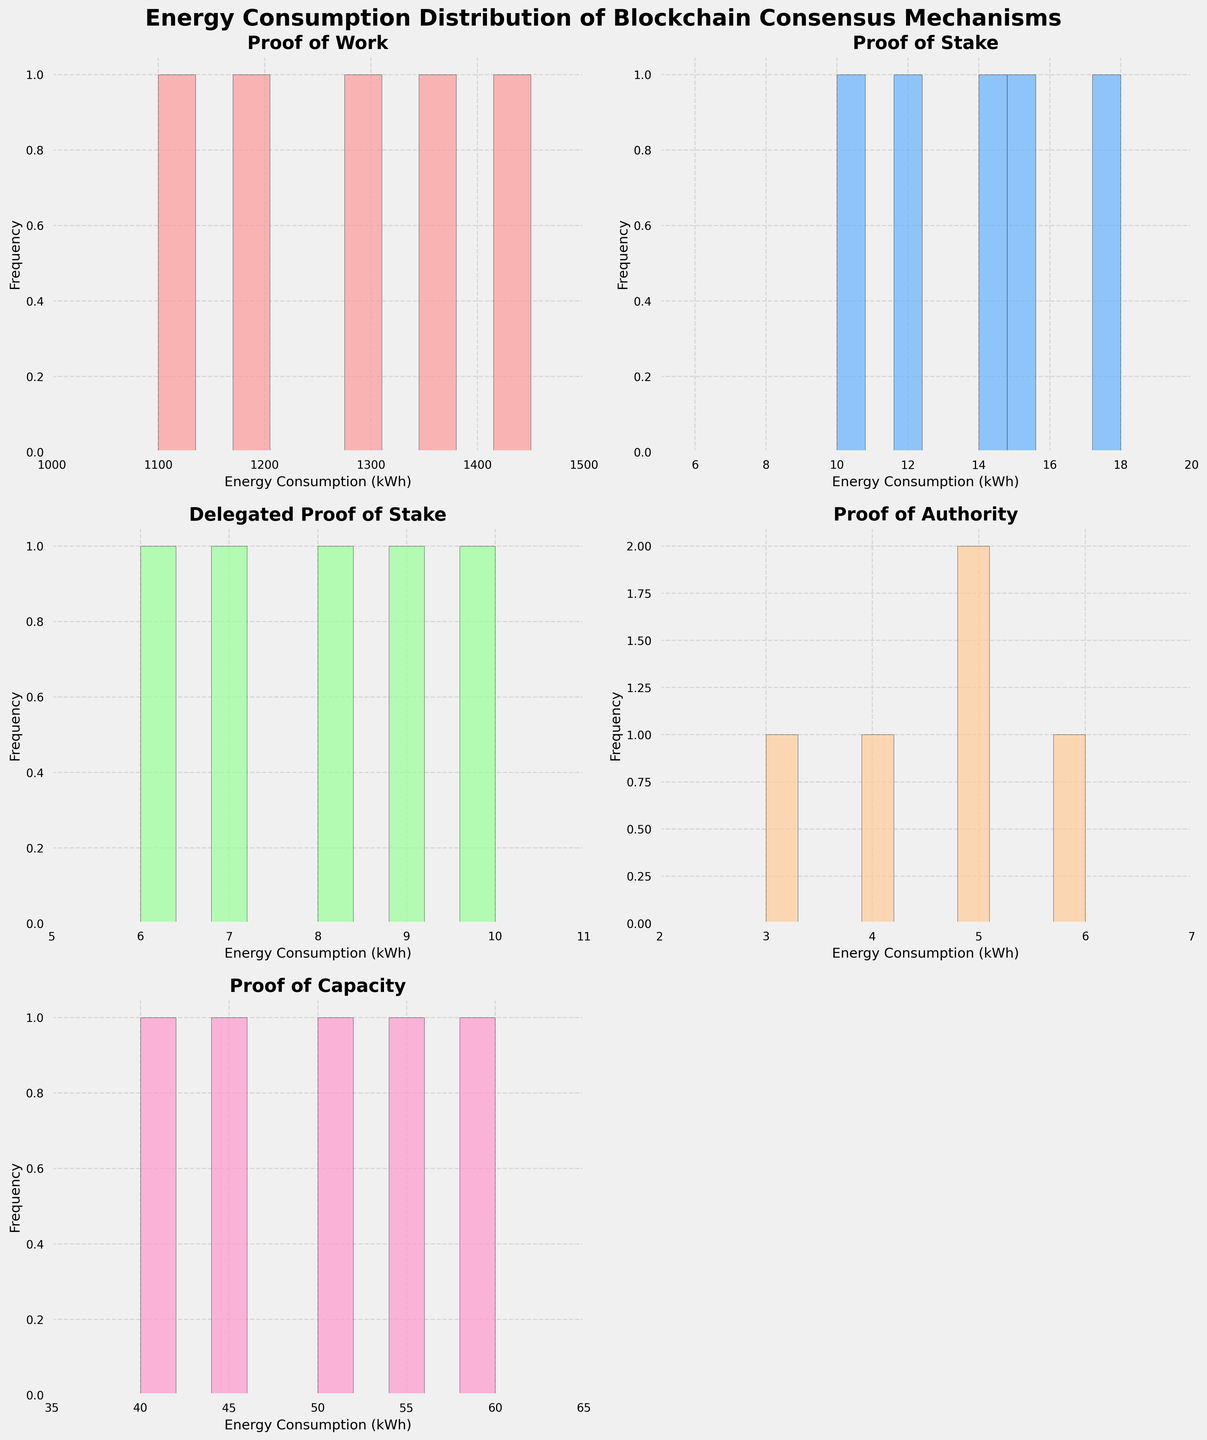What is the title of the figure? The title is prominently displayed at the top of the figure. It reads "Energy Consumption Distribution of Blockchain Consensus Mechanisms".
Answer: Energy Consumption Distribution of Blockchain Consensus Mechanisms Which consensus mechanism has the highest upper limit on the x-axis? By examining the x-axis limits for each subplot, the Proof of Work mechanism has the highest upper limit of 1500 kWh, as indicated by the x-axis range from 1000 to 1500 kWh.
Answer: Proof of Work Which consensus mechanism shows the narrowest range of energy consumption? By comparing the x-axis ranges of each mechanism, Proof of Authority has the narrowest range, from 2 to 7 kWh.
Answer: Proof of Authority What is the total number of histogram subplots in the figure? The figure contains a grid of histogram subplots, and there are 5 in total, one for each consensus mechanism, with one empty slot due to the grid layout.
Answer: 5 What is the most common range of energy consumption for Proof of Stake? By examining the histogram for Proof of Stake, the most common range (mode) lies between 10 and 15 kWh, as it has the highest frequency bar within this range.
Answer: 10-15 kWh How does the energy consumption range for Proof of Capacity compare to that of Proof of Stake? Proof of Capacity has an energy range of 35 to 65 kWh, whereas Proof of Stake has a range of 5 to 20 kWh, indicating that Proof of Capacity consumes more energy overall.
Answer: Proof of Capacity is higher Is there overlap in energy consumption among Proof of Stake, Delegated Proof of Stake, and Proof of Authority? Proof of Stake (5 to 20 kWh), Delegated Proof of Stake (5 to 11 kWh), and Proof of Authority (2 to 7 kWh) all share some ranges, with overlapping occurring particularly between 5 and 7 kWh.
Answer: Yes For which consensus mechanism does the histogram show the highest frequency bar? Examining the histograms, the highest frequency bar appears for the Proof of Stake mechanism, specifically in the 10-15 kWh range.
Answer: Proof of Stake Describe the color scheme used for the histograms. Each histogram uses a distinct color with some transparency. The mechanistic orders follow: Proof of Work (light red), Proof of Stake (light blue), Delegated Proof of Stake (light green), Proof of Authority (light orange), and Proof of Capacity (light pink).
Answer: Various light colors 